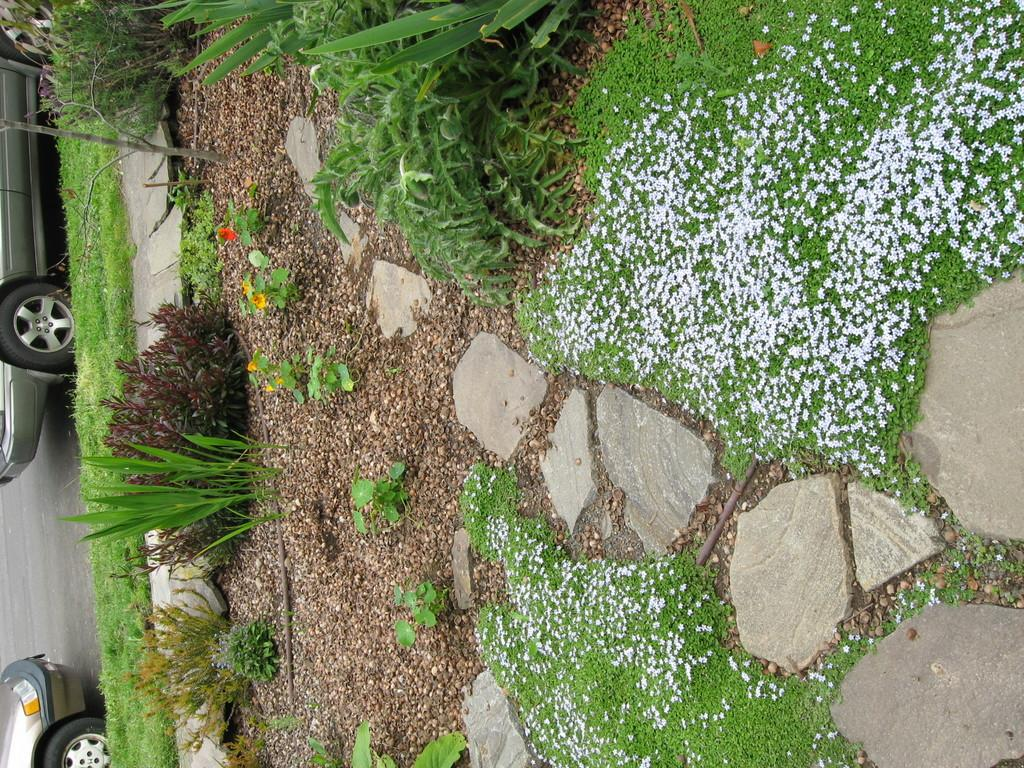What can be seen on the road in the image? There are vehicles on the road in the image. How much of the vehicles can be seen? The vehicles are only partially visible. What type of vegetation is present in the image? There is green grass, plants, and flowers in the image. What is the surface of the ground in the image? There is a rock surface in the image. What type of beef is being sold at the market in the image? There is no market or beef present in the image. What kind of experience can be gained from looking at the image? The image itself does not provide an experience, but it may evoke feelings or thoughts based on the viewer's interpretation. 